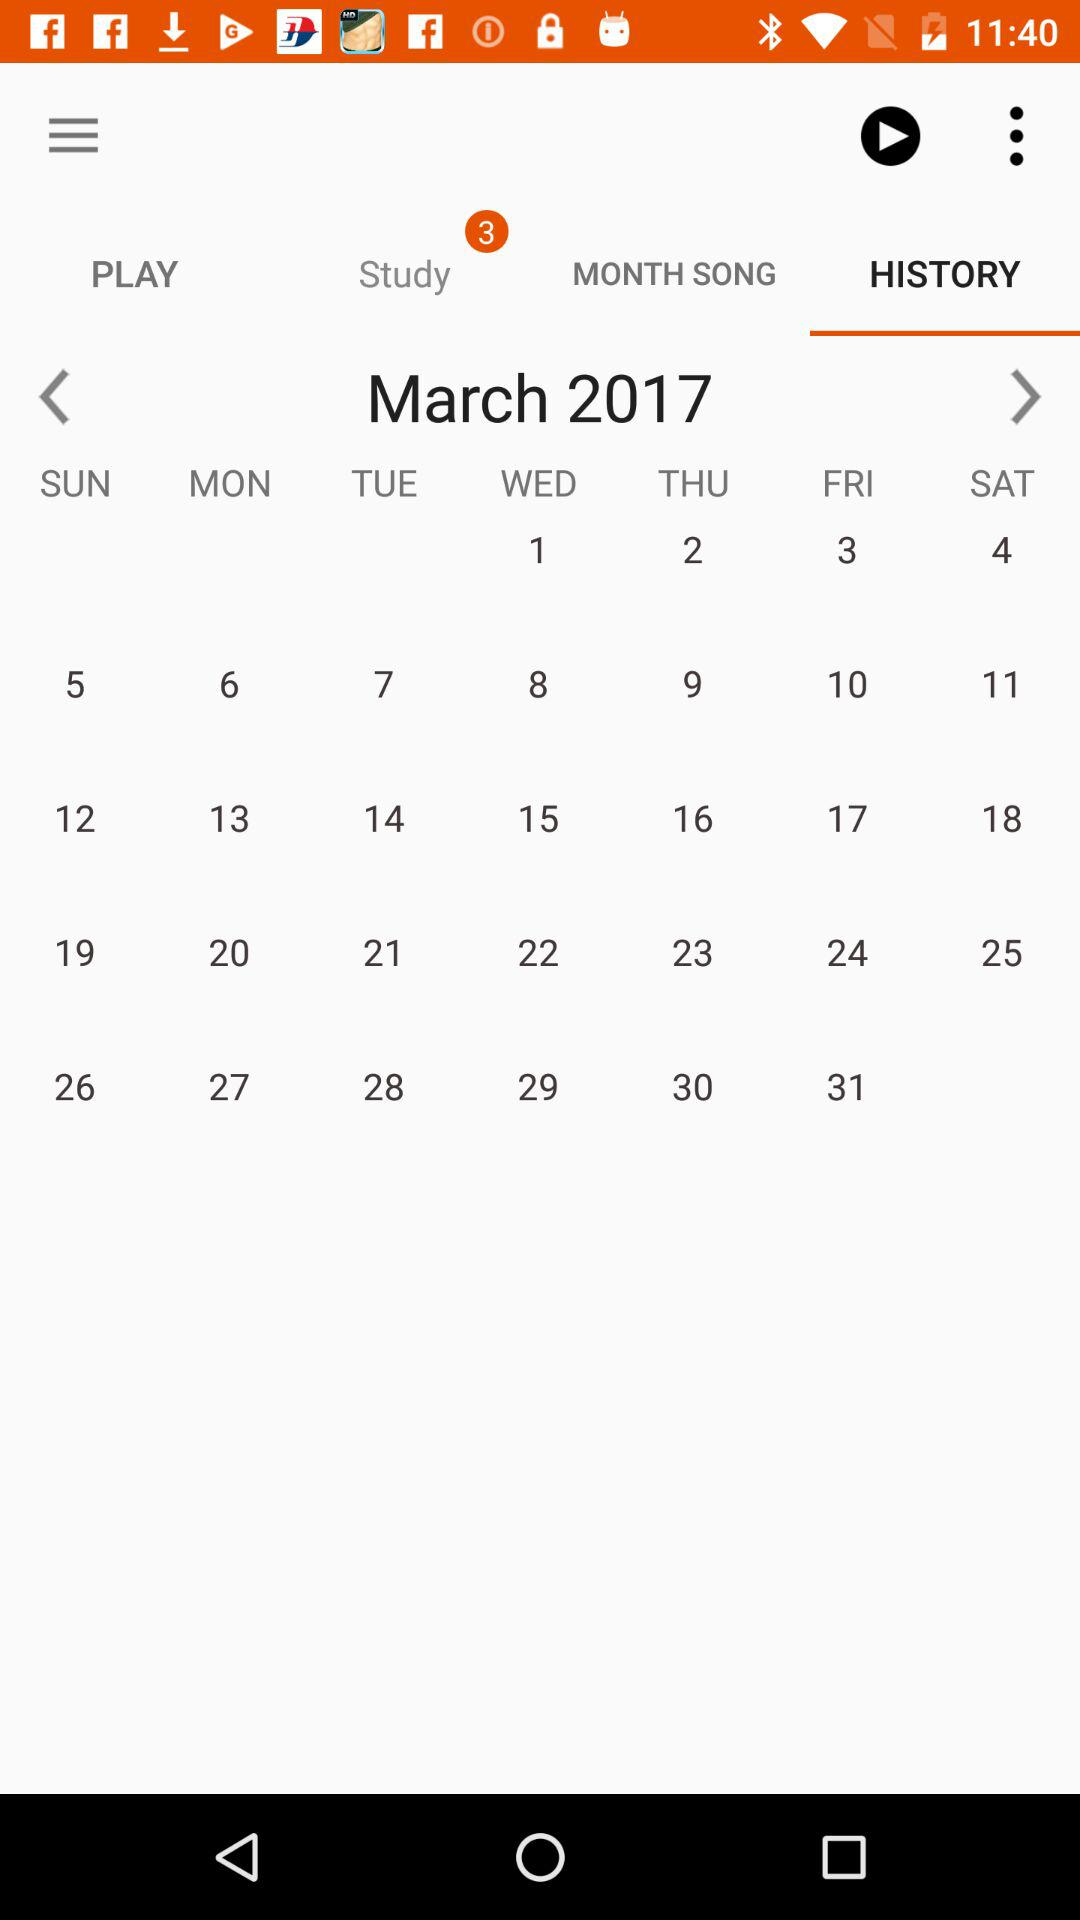Which tab is selected? The selected tab is "HISTORY". 